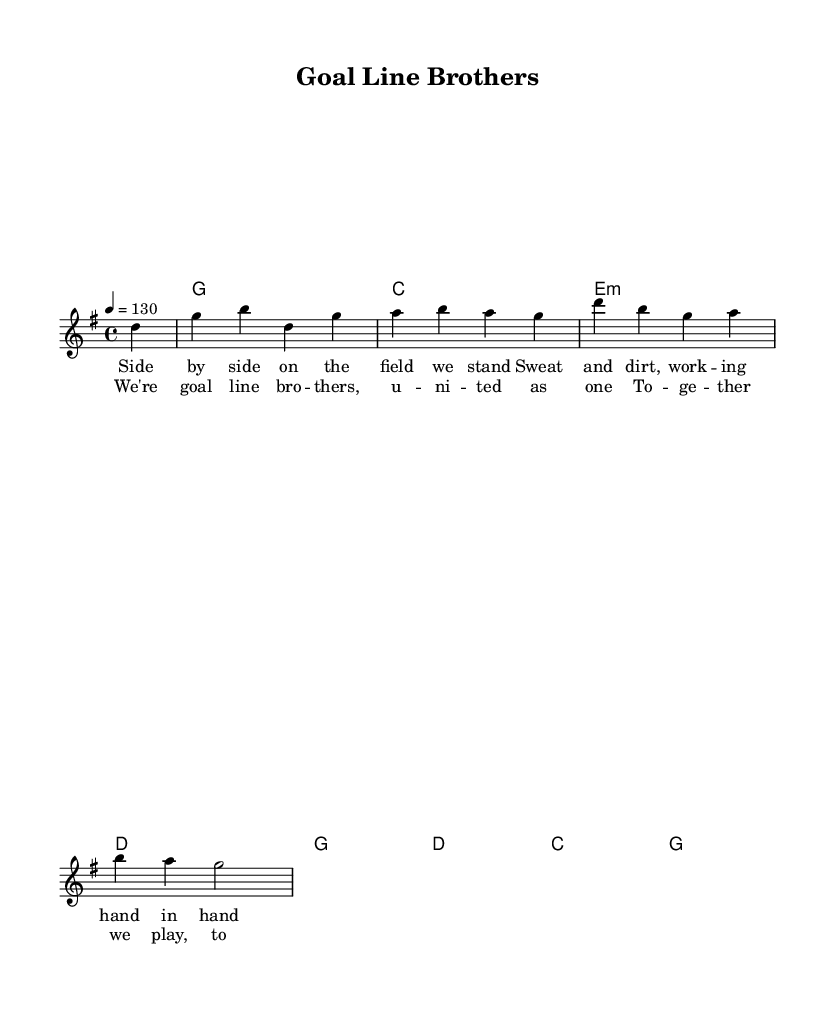What is the key signature of this music? The key signature indicated is G major, which has one sharp (F#).
Answer: G major What is the time signature of this piece? The time signature shown is 4/4, meaning there are four beats in a measure and a quarter note receives one beat.
Answer: 4/4 What is the tempo marking of the piece? The tempo marking says "4 = 130", which indicates a moderately fast tempo of 130 beats per minute.
Answer: 130 How many measures are there in the melody section? The melody section contains a total of five measures, as observed by counting the vertical lines that indicate measure separations.
Answer: Five What are the first two words of the chorus? The first two words of the chorus are "We're goal", as noted from the lyrics provided.
Answer: We're goal What is the overall theme of the song? The theme revolves around camaraderie and unity in team sports, as reflected in both the lyrics and the overall title "Goal Line Brothers".
Answer: Camaraderie Which chord comes after the second melody note? The chord following the second melody note 'b' in the first measure is G major, as indicated in the harmonies.
Answer: G 